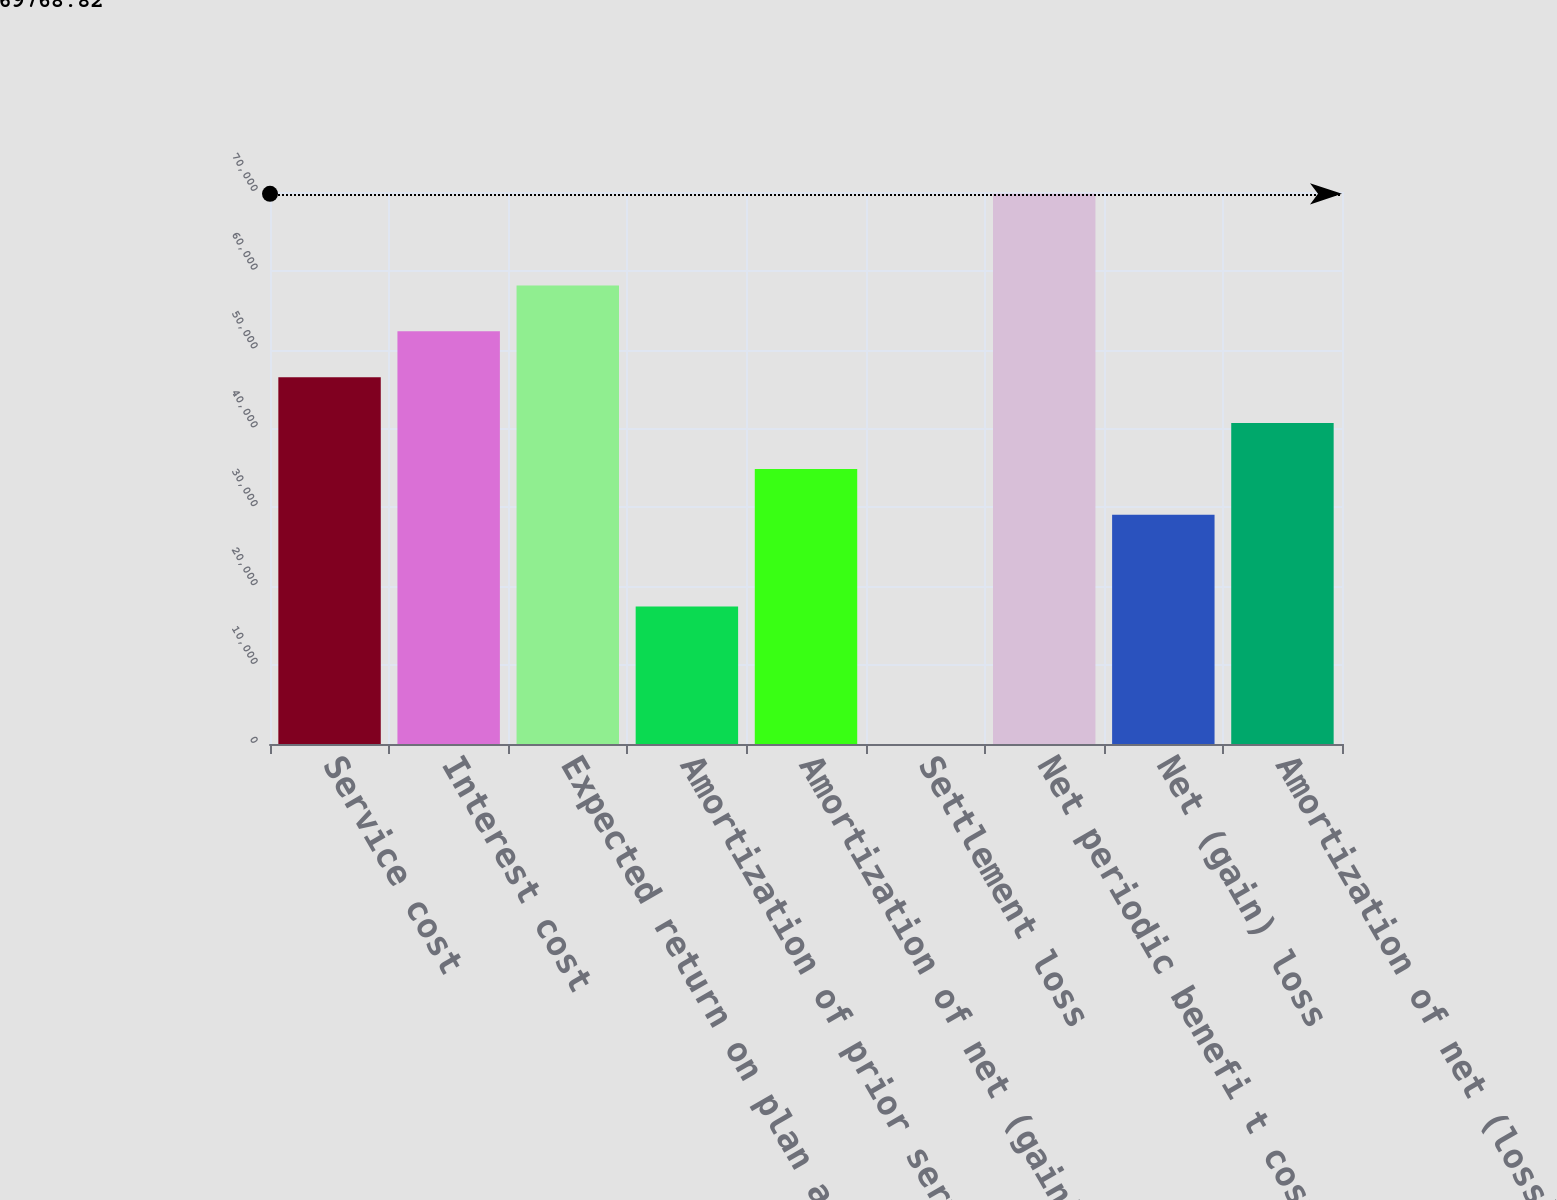Convert chart to OTSL. <chart><loc_0><loc_0><loc_500><loc_500><bar_chart><fcel>Service cost<fcel>Interest cost<fcel>Expected return on plan assets<fcel>Amortization of prior service<fcel>Amortization of net (gain)<fcel>Settlement loss<fcel>Net periodic benefi t cost<fcel>Net (gain) loss<fcel>Amortization of net (loss)<nl><fcel>46513.2<fcel>52327.1<fcel>58141<fcel>17443.6<fcel>34885.4<fcel>1.9<fcel>69768.8<fcel>29071.5<fcel>40699.3<nl></chart> 